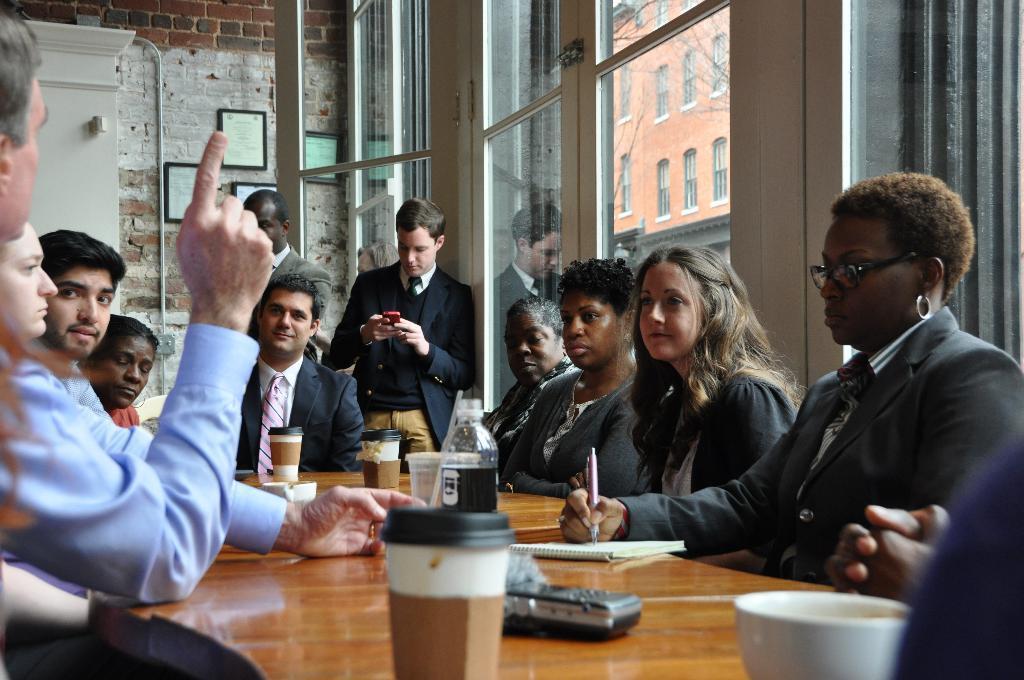Please provide a concise description of this image. This is an inside view. Here I can see many people are sitting around the table. On the table few glasses, bottle, book and a mobile are placed. Everyone is looking at the man who is on the left side. In the background two men are standing. One man is holding a mobile in the hands and looking into the mobile. At the back of these people there is a wall to which few frames are attached and also there is a glass through which we can see the outside view. In the outside there is a building. 